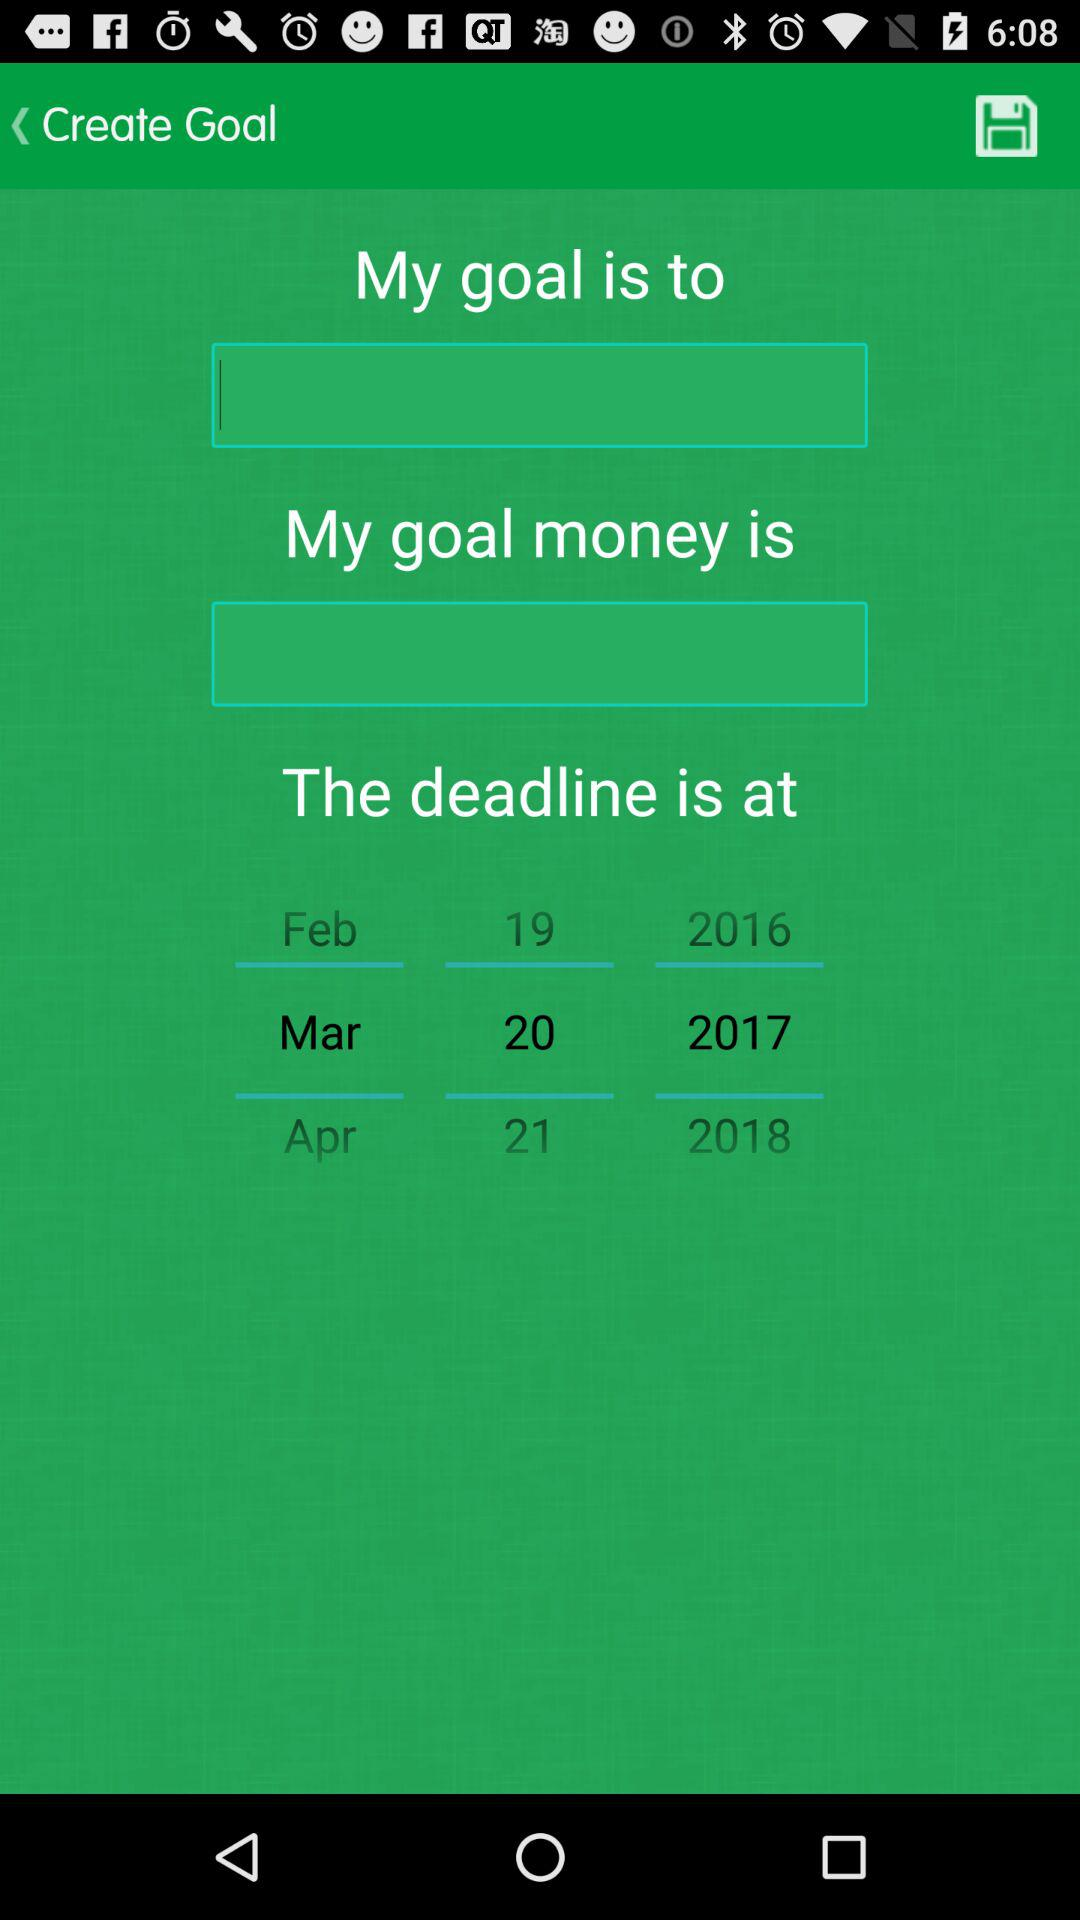What is the deadline date? The deadline date is March 20, 2017. 